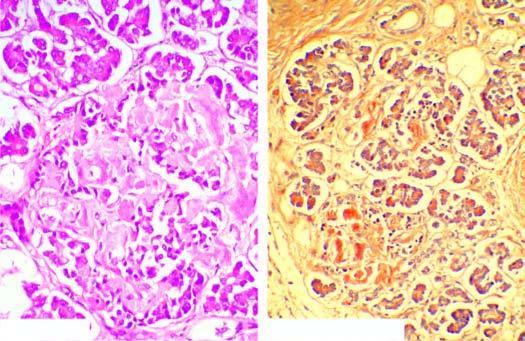what are mostly replaced by structureless eosinophilic material which stains positively with congo red?
Answer the question using a single word or phrase. Islets 